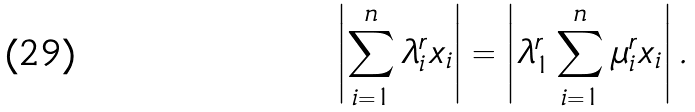Convert formula to latex. <formula><loc_0><loc_0><loc_500><loc_500>\left | \sum _ { i = 1 } ^ { n } \lambda _ { i } ^ { r } x _ { i } \right | = \left | \lambda _ { 1 } ^ { r } \sum _ { i = 1 } ^ { n } \mu _ { i } ^ { r } x _ { i } \right | .</formula> 